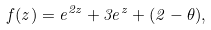Convert formula to latex. <formula><loc_0><loc_0><loc_500><loc_500>f ( z ) = e ^ { 2 z } + 3 e ^ { z } + ( 2 - \theta ) ,</formula> 